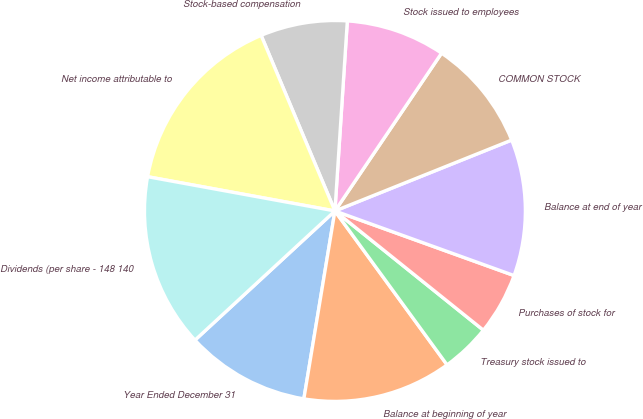Convert chart to OTSL. <chart><loc_0><loc_0><loc_500><loc_500><pie_chart><fcel>Year Ended December 31<fcel>Balance at beginning of year<fcel>Treasury stock issued to<fcel>Purchases of stock for<fcel>Balance at end of year<fcel>COMMON STOCK<fcel>Stock issued to employees<fcel>Stock-based compensation<fcel>Net income attributable to<fcel>Dividends (per share - 148 140<nl><fcel>10.53%<fcel>12.63%<fcel>4.21%<fcel>5.26%<fcel>11.58%<fcel>9.47%<fcel>8.42%<fcel>7.37%<fcel>15.79%<fcel>14.74%<nl></chart> 